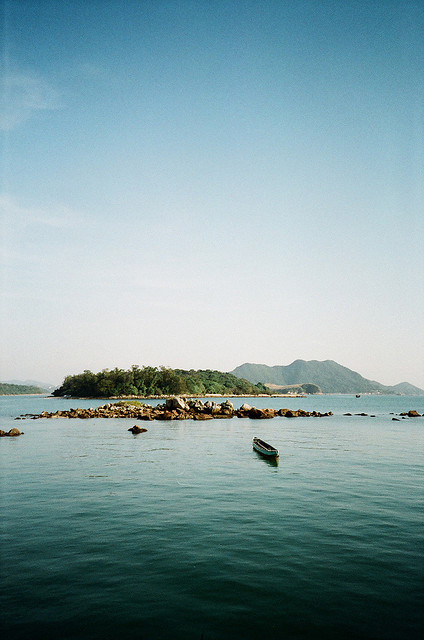<image>What is being flown? It is ambiguous what is being flown. It could be nothing or a kite. What is being flown? I don't know what is being flown. It can be nothing or a kite. 